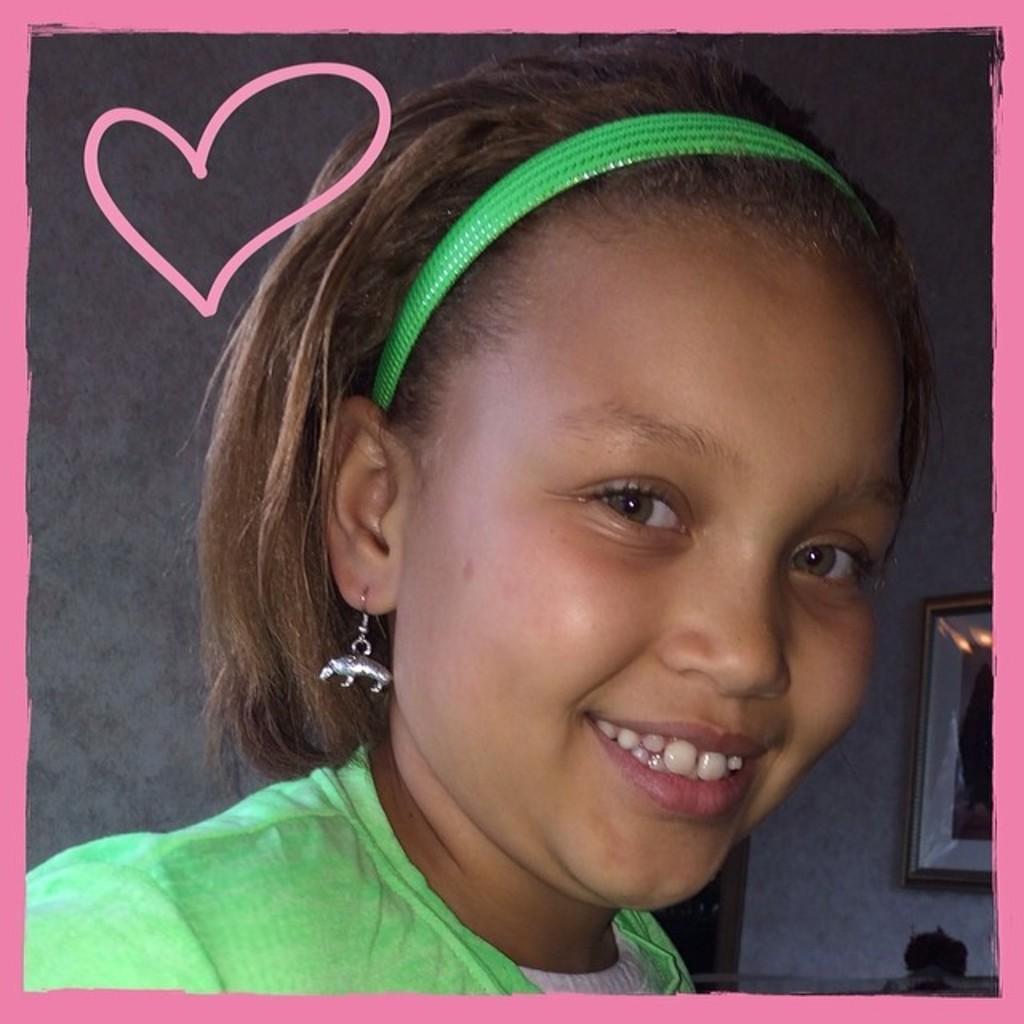In one or two sentences, can you explain what this image depicts? In this picture we can see a girl wearing a hair band and an earring. She is smiling. There is a frame visible on the wall in the background. We can see a pink color heart on the left side of a girl. We can see pink borders on this image. 